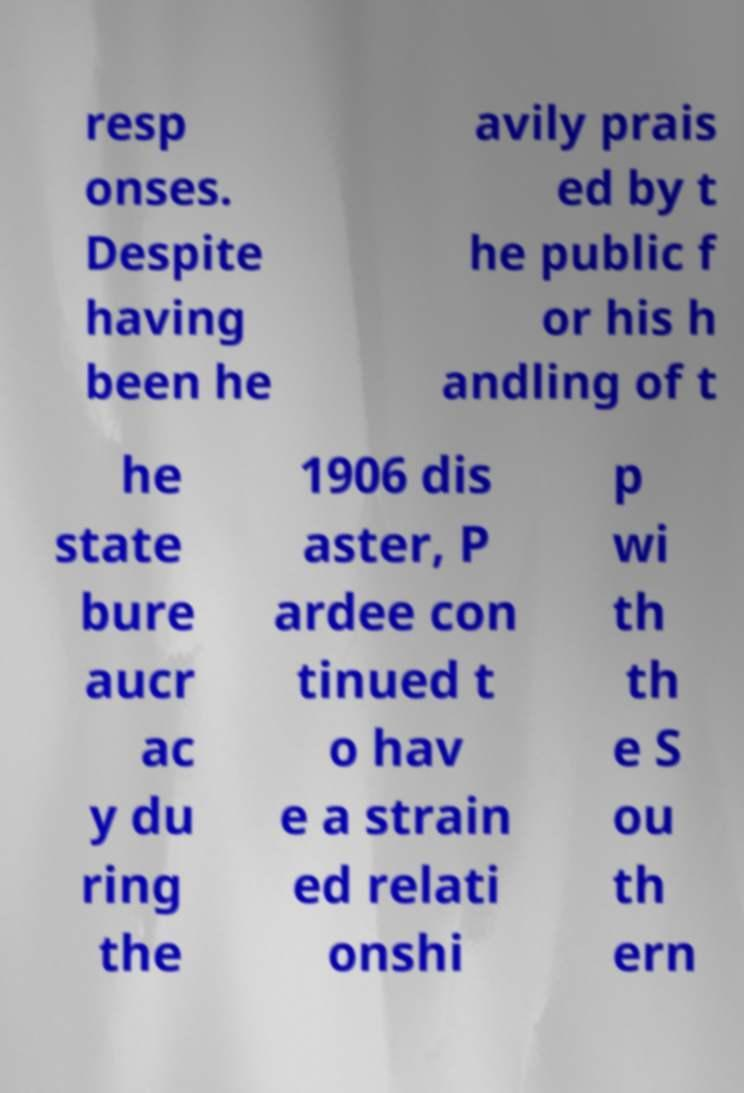Can you accurately transcribe the text from the provided image for me? resp onses. Despite having been he avily prais ed by t he public f or his h andling of t he state bure aucr ac y du ring the 1906 dis aster, P ardee con tinued t o hav e a strain ed relati onshi p wi th th e S ou th ern 